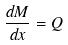Convert formula to latex. <formula><loc_0><loc_0><loc_500><loc_500>\frac { d M } { d x } = Q</formula> 